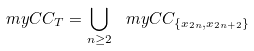Convert formula to latex. <formula><loc_0><loc_0><loc_500><loc_500>\ m y C C _ { T } = \bigcup _ { n \geq 2 } \ m y C C _ { \{ x _ { 2 n } , x _ { 2 n + 2 } \} }</formula> 